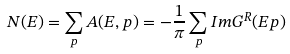<formula> <loc_0><loc_0><loc_500><loc_500>N ( E ) = \sum _ { p } A ( E , { p } ) = - \frac { 1 } { \pi } \sum _ { p } I m G ^ { R } ( E { p } )</formula> 